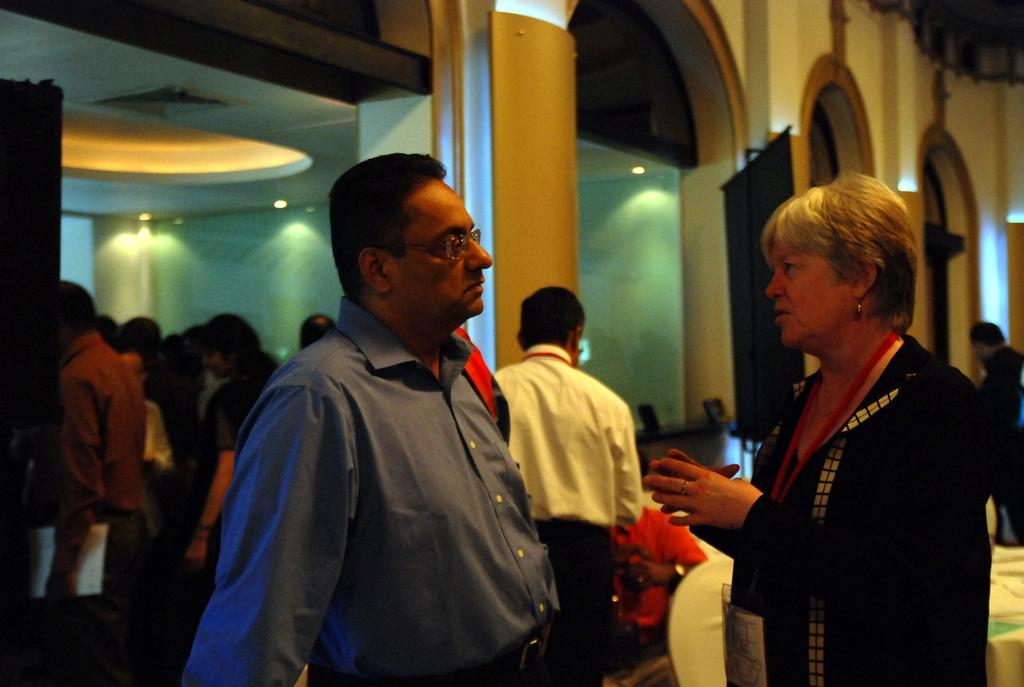How many people are in the image? There are people in the image. What is one person doing in the image? One person is sitting on a chair. What type of structures can be seen in the image? There are boards, pillars, and a wall in the image. What can be used for illumination in the image? There are lights in the image. What type of credit card does the dad use in the image? There is no dad or credit card present in the image. What type of bedroom furniture can be seen in the image? There is no bedroom furniture present in the image. 